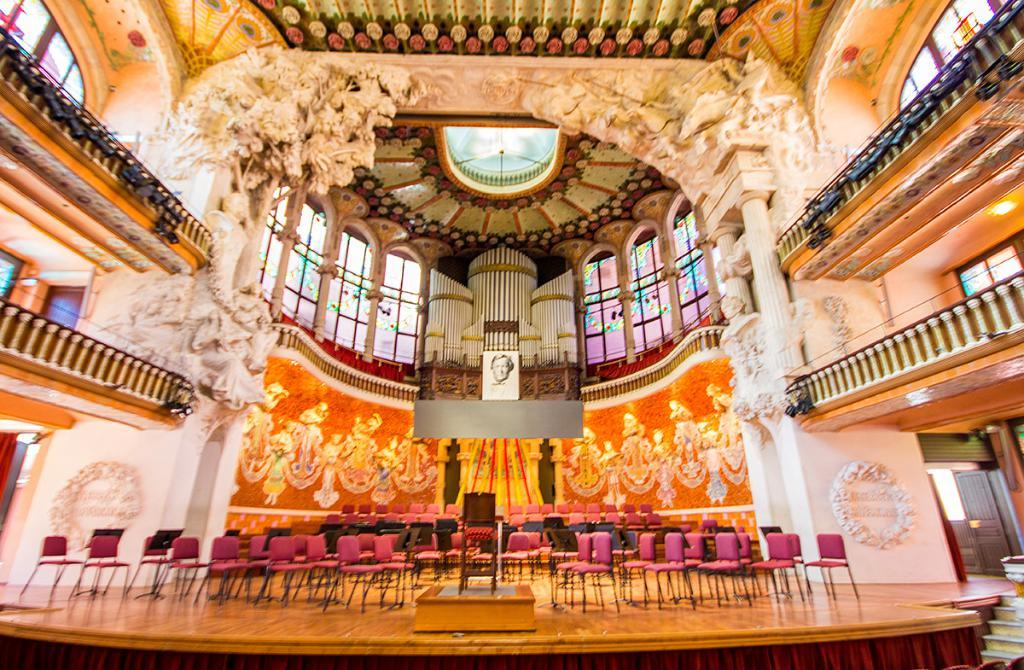Where was the image taken? The image was taken in a hall. What type of furniture can be seen at the bottom of the image? There are chairs at the bottom of the image. What is located on the right side of the image? There is a door on the right side of the image. What type of artwork is present in the image? Sculptures are present in the image. What architectural feature is visible in the image? Pillars are visible in the image. Can you tell me how many squirrels are sitting on the pillars in the image? There are no squirrels present in the image; it features a hall with chairs, a door, sculptures, and pillars. What type of writing can be seen on the sculptures in the image? There is no writing visible on the sculptures in the image. 